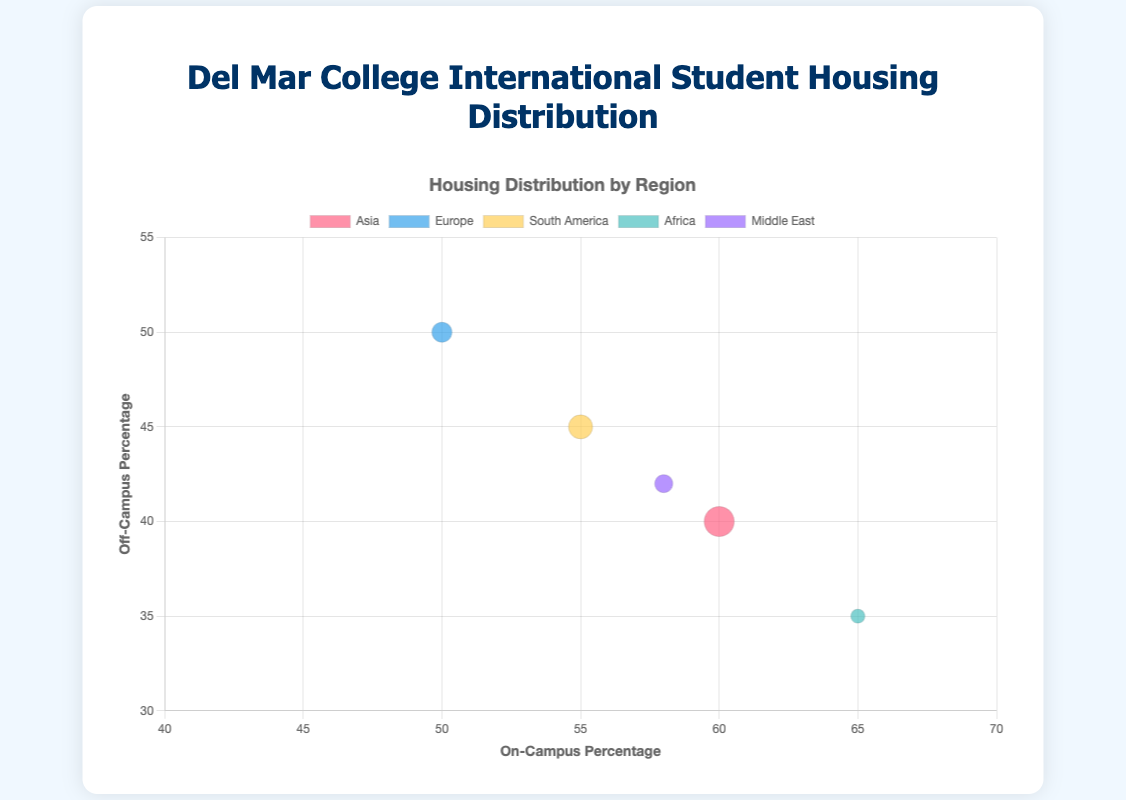Which region has the highest percentage of on-campus students? The chart shows that the region with the highest percentage of on-campus students is represented by the point farthest to the right on the x-axis, which is "Africa" (65%).
Answer: Africa Which region has the most balanced housing distribution between on-campus and off-campus? The chart indicates the most balanced distribution by the region whose bubble is closest to the middle of both the x and y axis ranges. "Europe" (50% on-campus and 50% off-campus) is the most balanced.
Answer: Europe What's the average on-campus percentage for all the student groups? The on-campus percentages for each group are 60, 50, 55, 65, and 58. Adding these together yields 60 + 50 + 55 + 65 + 58 = 288. Dividing by the number of groups (5) gives 288/5 = 57.6%.
Answer: 57.6% Which region has the smallest total student population? The size of the bubble represents the total student population. The smallest bubble is "Africa" represented by an area of 70.
Answer: Africa What's the median percentage of off-campus students across all groups? The off-campus percentages are 40, 50, 45, 35, and 42. Arranging them in order gives 35, 40, 42, 45, 50. The median value (the middle one in this ordered list) is 42%.
Answer: 42% Which region has a higher on-campus percentage, Asia or South America? On the x-axis, "Asia" is at 60% and "South America" is at 55%. 60% > 55%.
Answer: Asia How many regions have on-campus percentages that are above 55%? The regions with on-campus percentages above 55% are "Asia" (60%), "Africa" (65%), and "Middle East" (58%). There are three such regions.
Answer: 3 What is the combined total student population for Asia and Europe? According to the data, "Asia" has 150 students and "Europe" has 100 students. Adding these together gives 150 + 100 = 250 students.
Answer: 250 